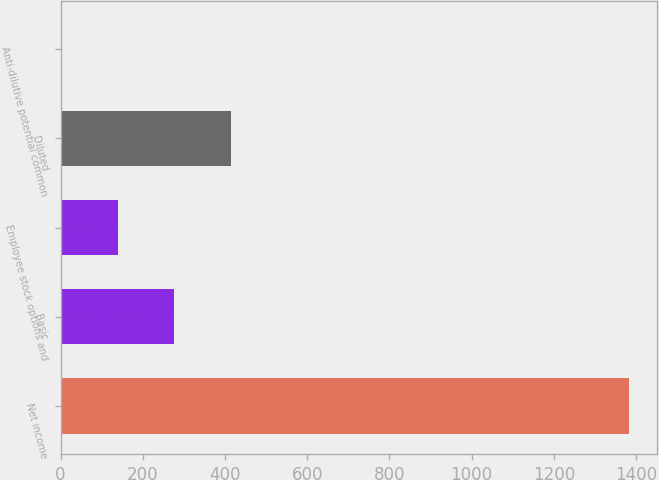Convert chart to OTSL. <chart><loc_0><loc_0><loc_500><loc_500><bar_chart><fcel>Net income<fcel>Basic<fcel>Employee stock options and<fcel>Diluted<fcel>Anti-dilutive potential common<nl><fcel>1382<fcel>277.2<fcel>139.1<fcel>415.3<fcel>1<nl></chart> 